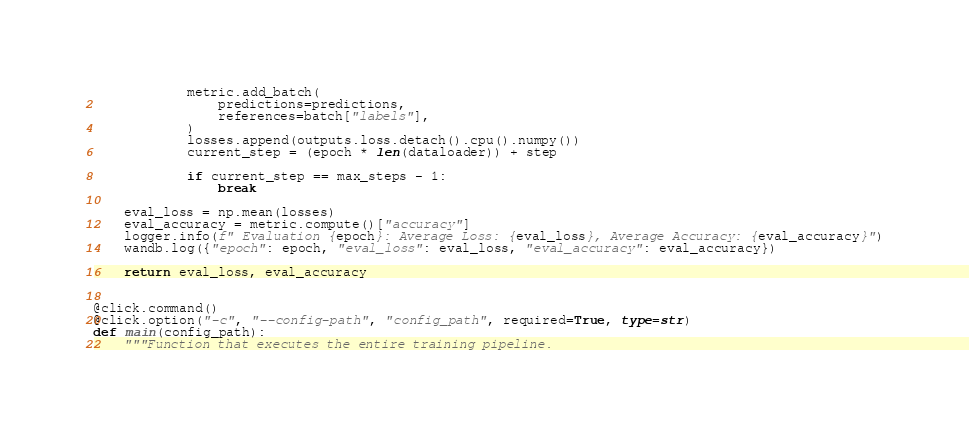Convert code to text. <code><loc_0><loc_0><loc_500><loc_500><_Python_>            metric.add_batch(
                predictions=predictions,
                references=batch["labels"],
            )
            losses.append(outputs.loss.detach().cpu().numpy())
            current_step = (epoch * len(dataloader)) + step

            if current_step == max_steps - 1:
                break

    eval_loss = np.mean(losses)
    eval_accuracy = metric.compute()["accuracy"]
    logger.info(f" Evaluation {epoch}: Average Loss: {eval_loss}, Average Accuracy: {eval_accuracy}")
    wandb.log({"epoch": epoch, "eval_loss": eval_loss, "eval_accuracy": eval_accuracy})

    return eval_loss, eval_accuracy


@click.command()
@click.option("-c", "--config-path", "config_path", required=True, type=str)
def main(config_path):
    """Function that executes the entire training pipeline.
</code> 